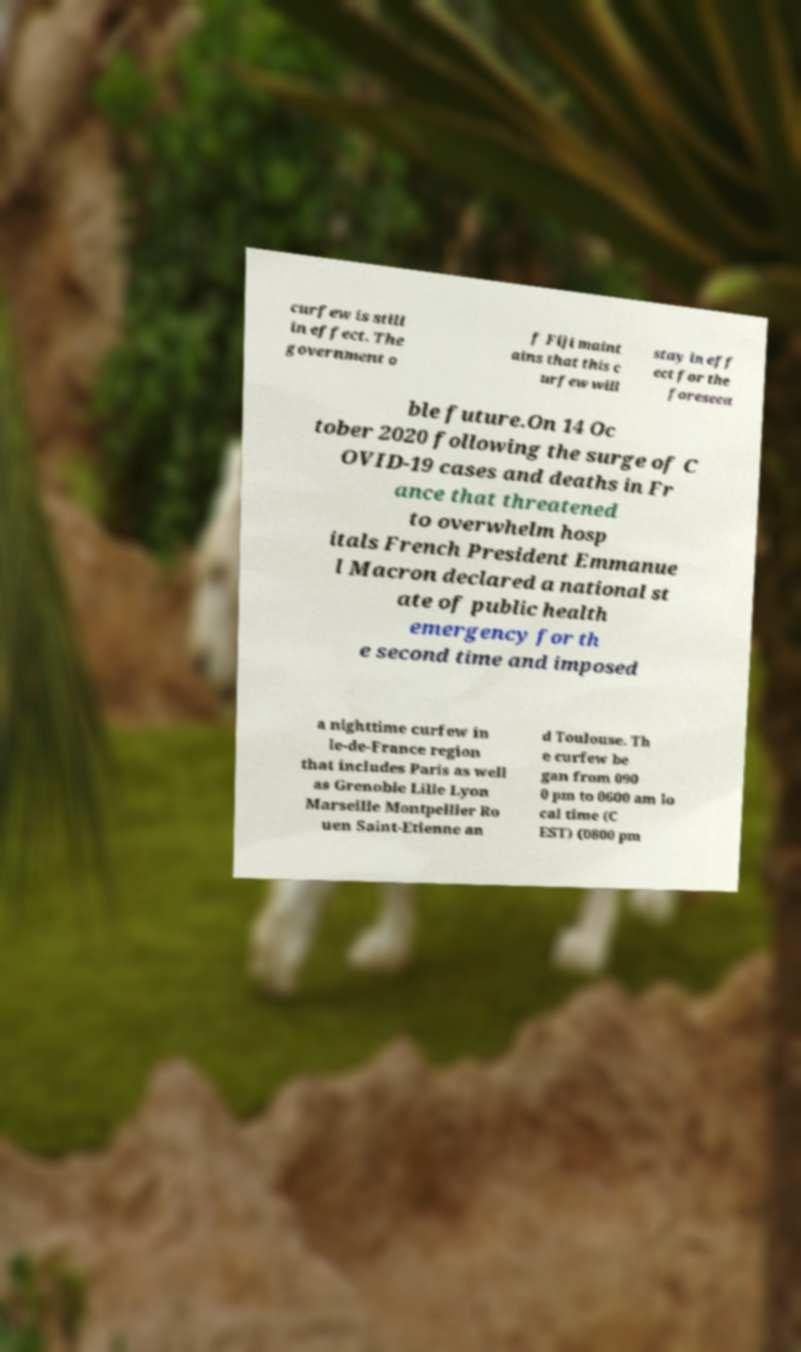Please read and relay the text visible in this image. What does it say? curfew is still in effect. The government o f Fiji maint ains that this c urfew will stay in eff ect for the foreseea ble future.On 14 Oc tober 2020 following the surge of C OVID-19 cases and deaths in Fr ance that threatened to overwhelm hosp itals French President Emmanue l Macron declared a national st ate of public health emergency for th e second time and imposed a nighttime curfew in le-de-France region that includes Paris as well as Grenoble Lille Lyon Marseille Montpellier Ro uen Saint-Etienne an d Toulouse. Th e curfew be gan from 090 0 pm to 0600 am lo cal time (C EST) (0800 pm 